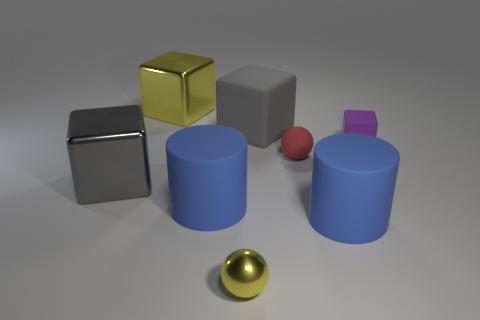Add 2 large yellow cubes. How many objects exist? 10 Subtract all purple matte blocks. How many blocks are left? 3 Add 1 blue rubber objects. How many blue rubber objects exist? 3 Subtract all yellow balls. How many balls are left? 1 Subtract 0 red blocks. How many objects are left? 8 Subtract all cylinders. How many objects are left? 6 Subtract 4 blocks. How many blocks are left? 0 Subtract all blue blocks. Subtract all blue balls. How many blocks are left? 4 Subtract all green blocks. How many purple cylinders are left? 0 Subtract all yellow cubes. Subtract all tiny yellow metal objects. How many objects are left? 6 